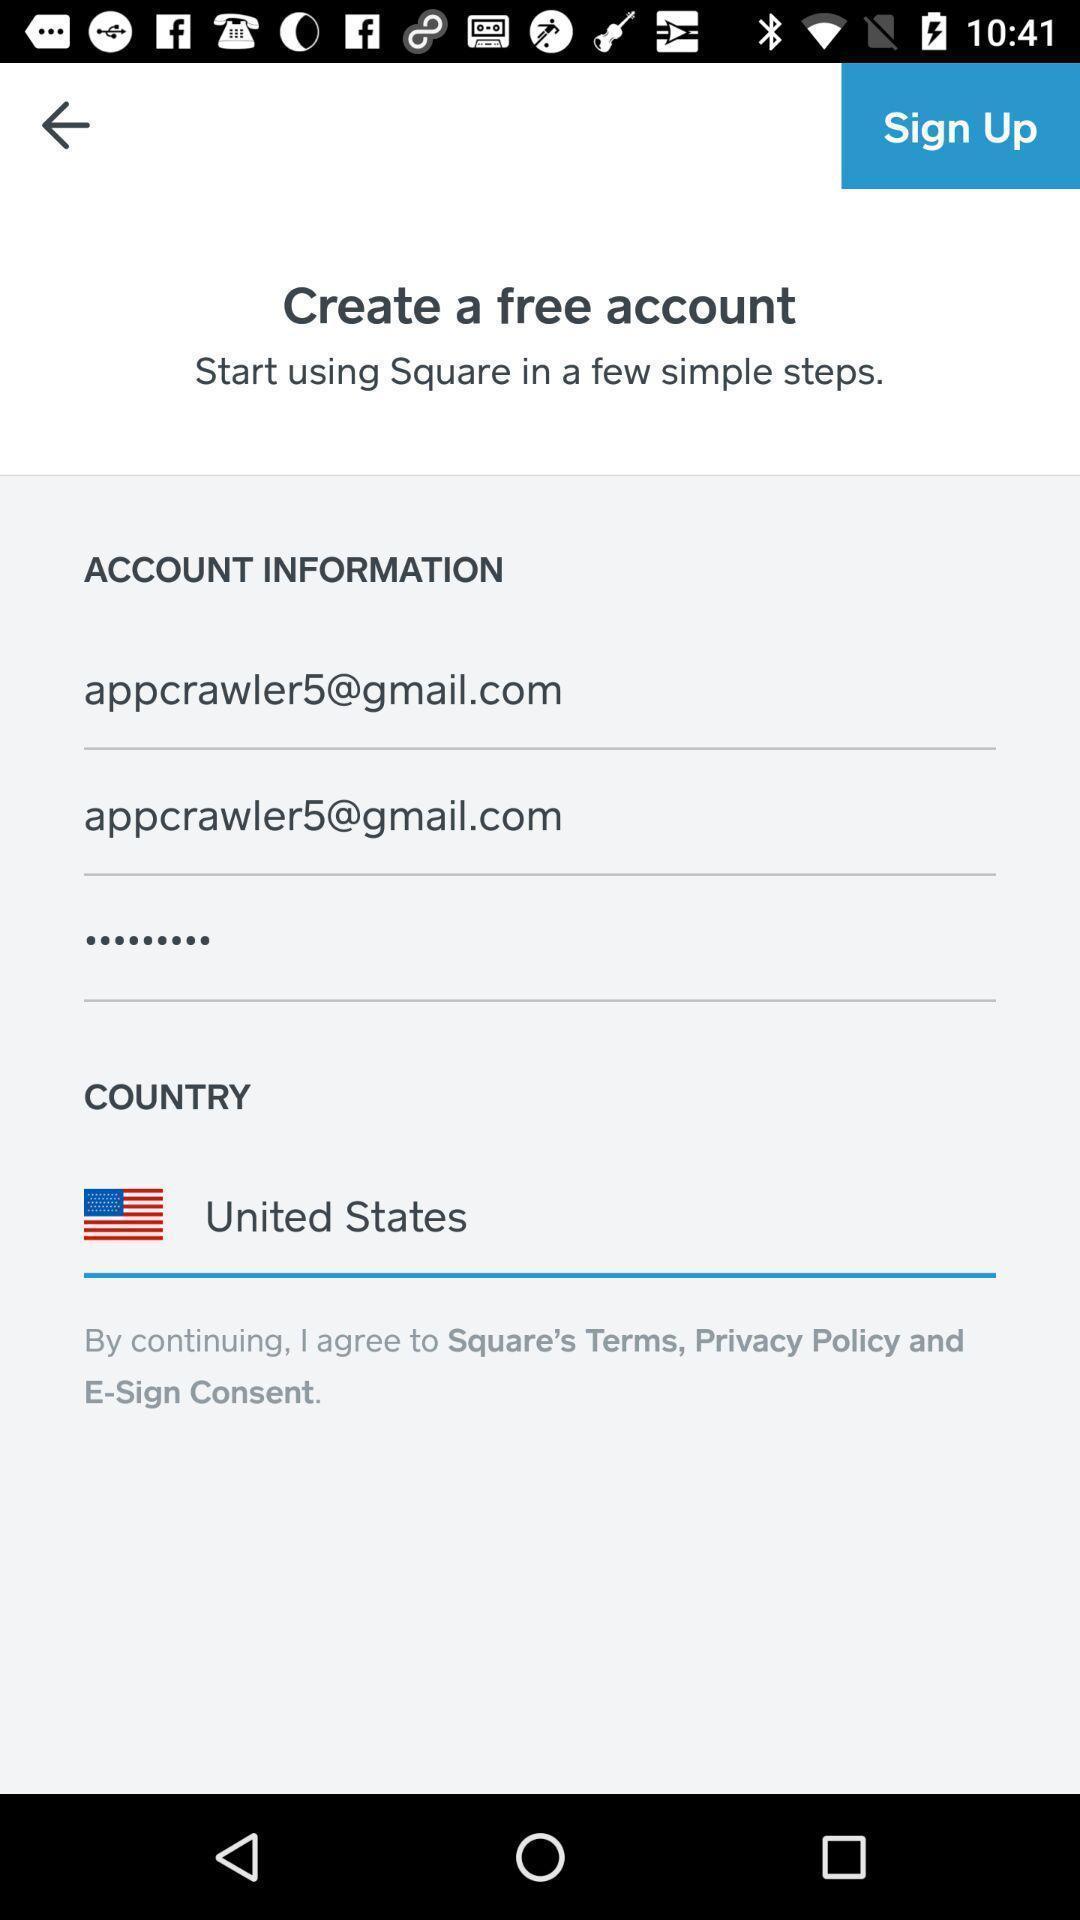Describe the visual elements of this screenshot. Sign up page shows to create an account. 